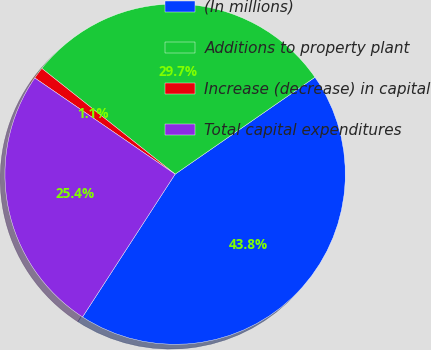<chart> <loc_0><loc_0><loc_500><loc_500><pie_chart><fcel>(In millions)<fcel>Additions to property plant<fcel>Increase (decrease) in capital<fcel>Total capital expenditures<nl><fcel>43.8%<fcel>29.68%<fcel>1.11%<fcel>25.41%<nl></chart> 